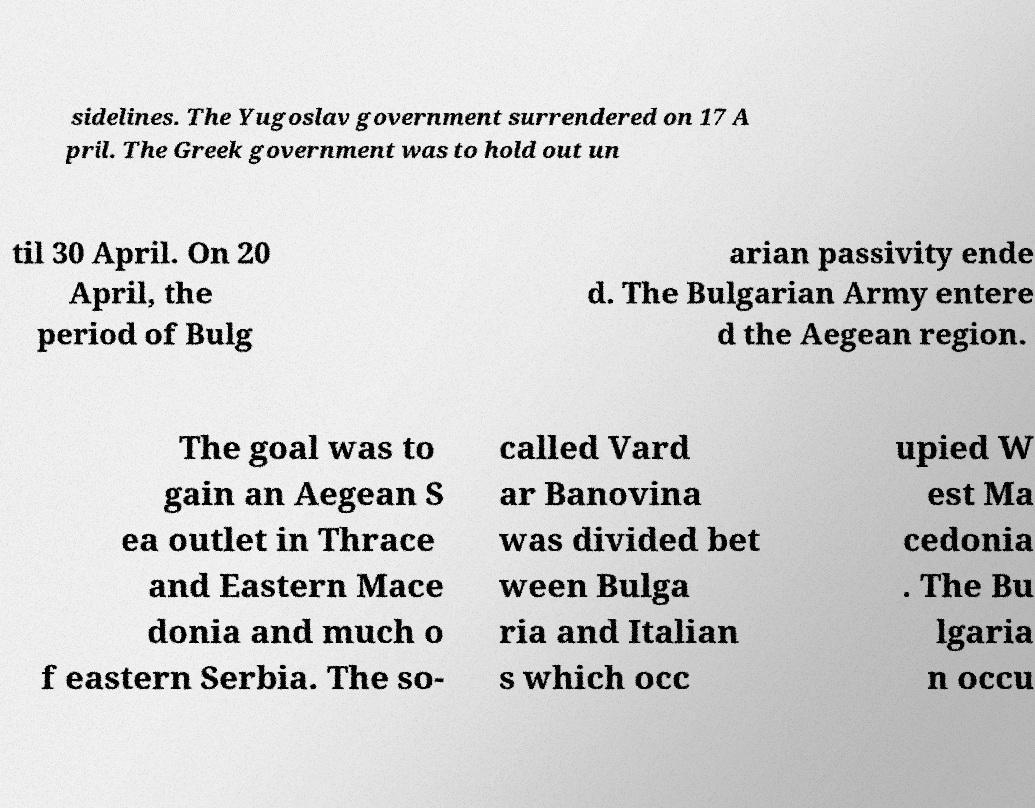I need the written content from this picture converted into text. Can you do that? sidelines. The Yugoslav government surrendered on 17 A pril. The Greek government was to hold out un til 30 April. On 20 April, the period of Bulg arian passivity ende d. The Bulgarian Army entere d the Aegean region. The goal was to gain an Aegean S ea outlet in Thrace and Eastern Mace donia and much o f eastern Serbia. The so- called Vard ar Banovina was divided bet ween Bulga ria and Italian s which occ upied W est Ma cedonia . The Bu lgaria n occu 